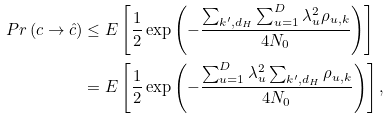Convert formula to latex. <formula><loc_0><loc_0><loc_500><loc_500>P r \left ( c \rightarrow \hat { c } \right ) & \leq E \left [ \frac { 1 } { 2 } \exp \left ( - \frac { \sum _ { k ^ { \prime } , d _ { H } } \sum _ { u = 1 } ^ { D } \lambda _ { u } ^ { 2 } \rho _ { u , k } } { 4 N _ { 0 } } \right ) \right ] \\ & = E \left [ \frac { 1 } { 2 } \exp \left ( - \frac { \sum _ { u = 1 } ^ { D } \lambda _ { u } ^ { 2 } \sum _ { k ^ { \prime } , d _ { H } } \rho _ { u , k } } { 4 N _ { 0 } } \right ) \right ] ,</formula> 